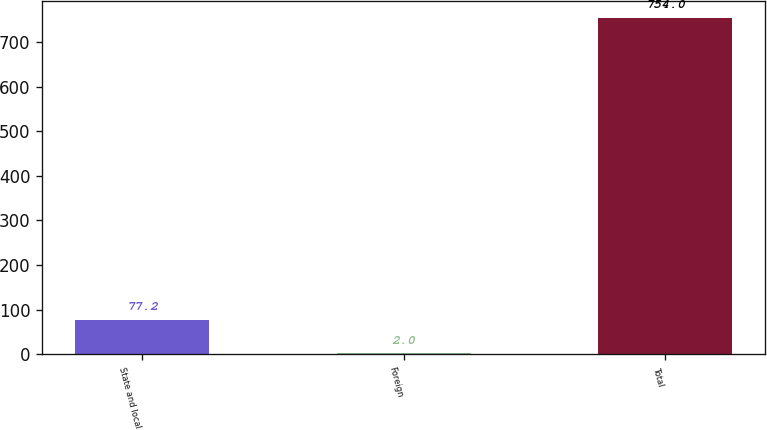<chart> <loc_0><loc_0><loc_500><loc_500><bar_chart><fcel>State and local<fcel>Foreign<fcel>Total<nl><fcel>77.2<fcel>2<fcel>754<nl></chart> 